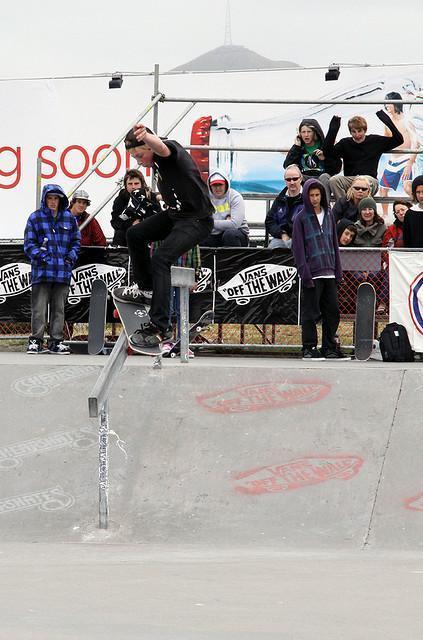How many people can be seen?
Give a very brief answer. 9. 